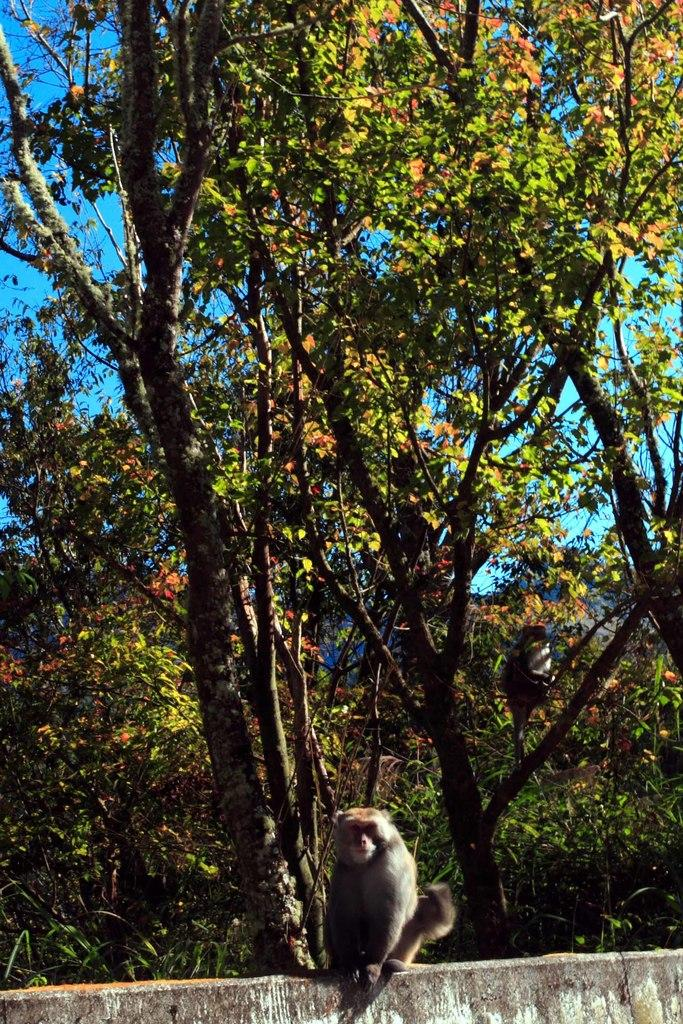What is located in the foreground of the image? There is a wall in the foreground of the image. What type of animal can be seen in the image? There is a monkey in the image. What other natural elements are present in the image? There are trees in the image. What other living creature can be seen in the image? There is a bird in the image. What is visible in the background of the image? The sky is visible in the image. What type of bean is the monkey holding in the image? There is no bean present in the image; the monkey is not holding anything. 